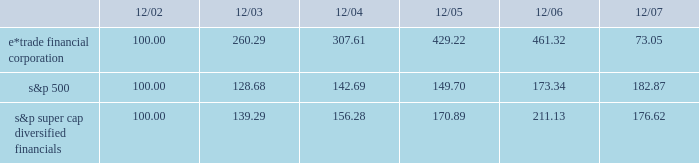December 18 , 2007 , we issued an additional 23182197 shares of common stock to citadel .
The issuances were exempt from registration pursuant to section 4 ( 2 ) of the securities act of 1933 , and each purchaser has represented to us that it is an 201caccredited investor 201d as defined in regulation d promulgated under the securities act of 1933 , and that the common stock was being acquired for investment .
We did not engage in a general solicitation or advertising with regard to the issuances of the common stock and have not offered securities to the public in connection with the issuances .
See item 1 .
Business 2014citadel investment .
Performance graph the following performance graph shows the cumulative total return to a holder of the company 2019s common stock , assuming dividend reinvestment , compared with the cumulative total return , assuming dividend reinvestment , of the standard & poor 2019s ( 201cs&p 201d ) 500 and the s&p super cap diversified financials during the period from december 31 , 2002 through december 31 , 2007. .
2022 $ 100 invested on 12/31/02 in stock or index-including reinvestment of dividends .
Fiscal year ending december 31 .
2022 copyright a9 2008 , standard & poor 2019s , a division of the mcgraw-hill companies , inc .
All rights reserved .
Www.researchdatagroup.com/s&p.htm .
What was the difference in percentage cumulative total return between e*trade financial corporation and s&p super cap diversified financials for the five years ended 12/07? 
Computations: (((73.05 - 100) / 100) - ((176.62 - 100) / 100))
Answer: -1.0357. 